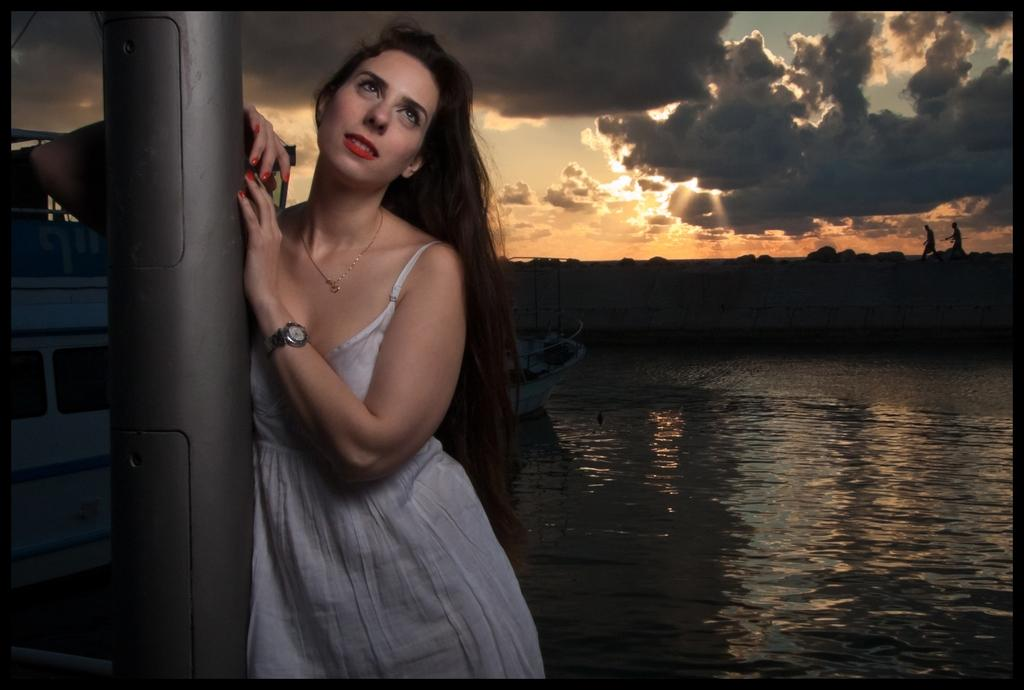What is the girl doing in the image? The girl is standing near a pole in the image. What can be seen in the background of the image? There is a ship on the river and two people walking in the background of the image. What is visible in the sky in the image? The sky is visible in the image. What type of tooth is visible on the girl's face in the image? There is no tooth visible on the girl's face in the image. What mark can be seen on the ship in the background of the image? There is no mark visible on the ship in the background of the image. 